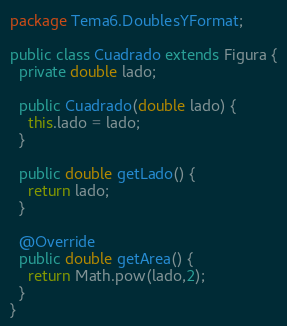Convert code to text. <code><loc_0><loc_0><loc_500><loc_500><_Java_>package Tema6.DoublesYFormat;

public class Cuadrado extends Figura {
  private double lado;

  public Cuadrado(double lado) {
    this.lado = lado;
  }

  public double getLado() {
    return lado;
  }

  @Override
  public double getArea() {
    return Math.pow(lado,2);
  }
}
</code> 